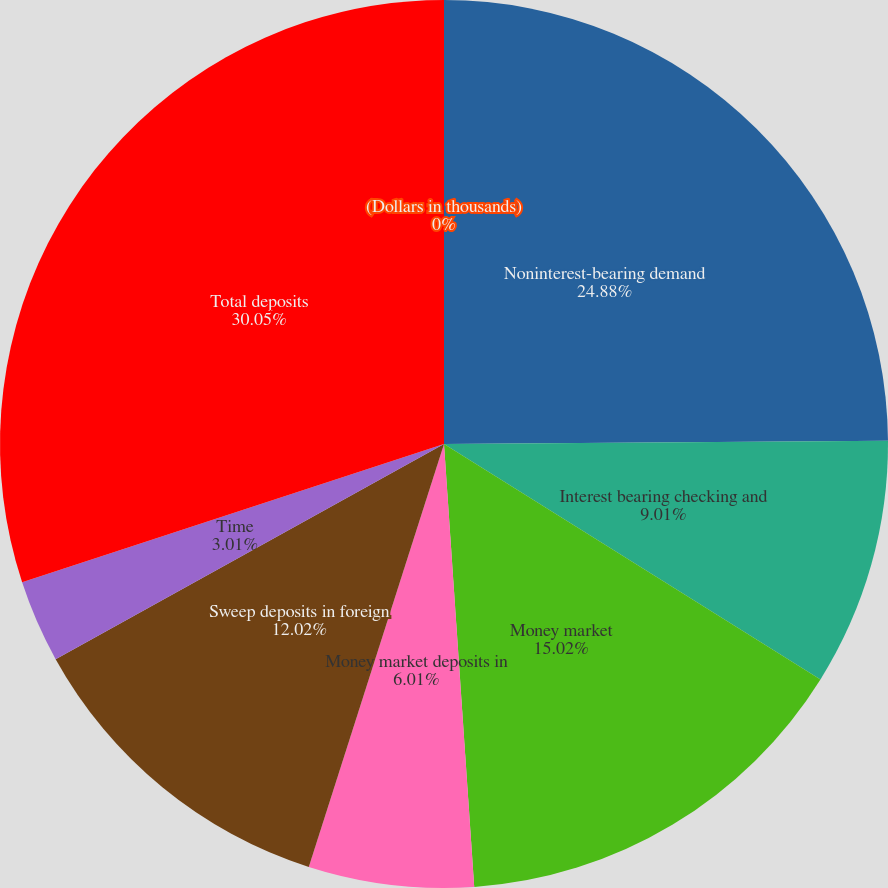<chart> <loc_0><loc_0><loc_500><loc_500><pie_chart><fcel>(Dollars in thousands)<fcel>Noninterest-bearing demand<fcel>Interest bearing checking and<fcel>Money market<fcel>Money market deposits in<fcel>Sweep deposits in foreign<fcel>Time<fcel>Total deposits<nl><fcel>0.0%<fcel>24.88%<fcel>9.01%<fcel>15.02%<fcel>6.01%<fcel>12.02%<fcel>3.01%<fcel>30.04%<nl></chart> 